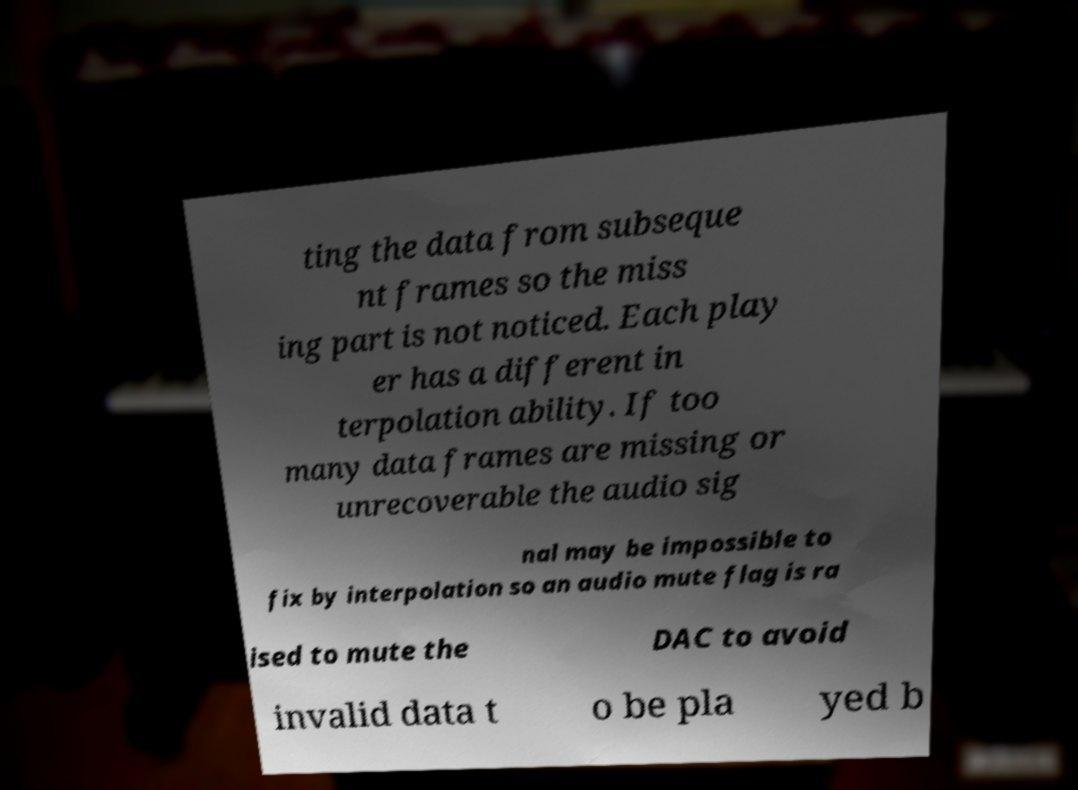Can you read and provide the text displayed in the image?This photo seems to have some interesting text. Can you extract and type it out for me? ting the data from subseque nt frames so the miss ing part is not noticed. Each play er has a different in terpolation ability. If too many data frames are missing or unrecoverable the audio sig nal may be impossible to fix by interpolation so an audio mute flag is ra ised to mute the DAC to avoid invalid data t o be pla yed b 